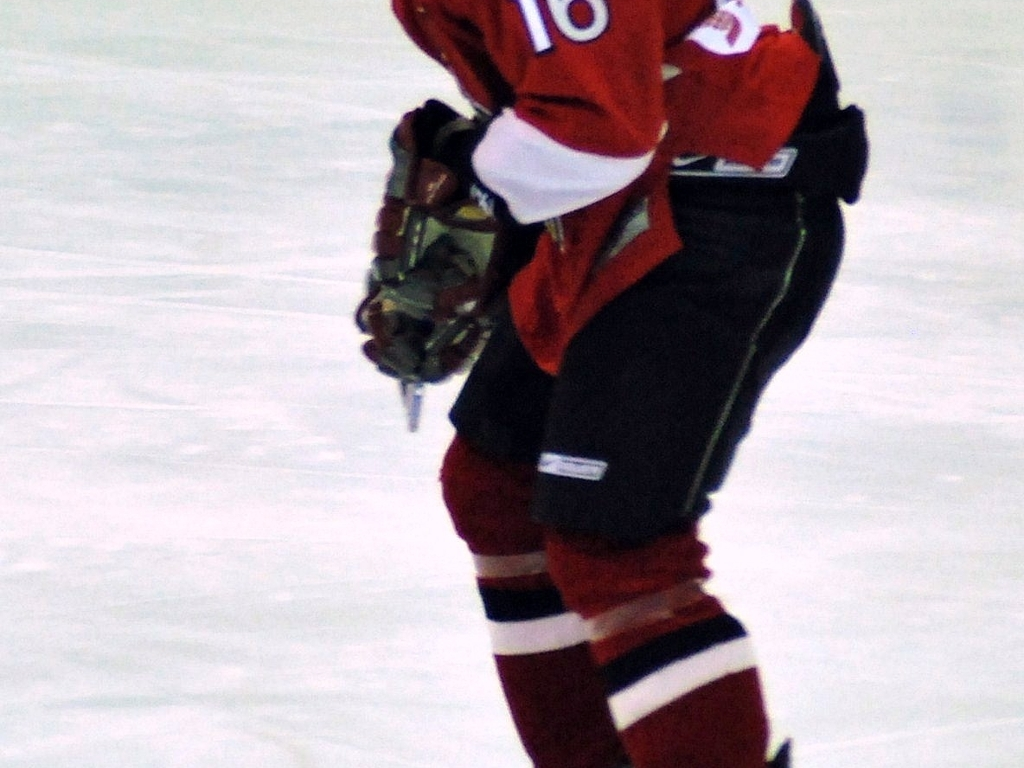Is the player in motion or stationary? It is difficult to say with certainty without additional context or a clearer image, but the player's posture suggests they might be gliding on the ice, possibly during a break in the action or while positioning themselves during gameplay. 